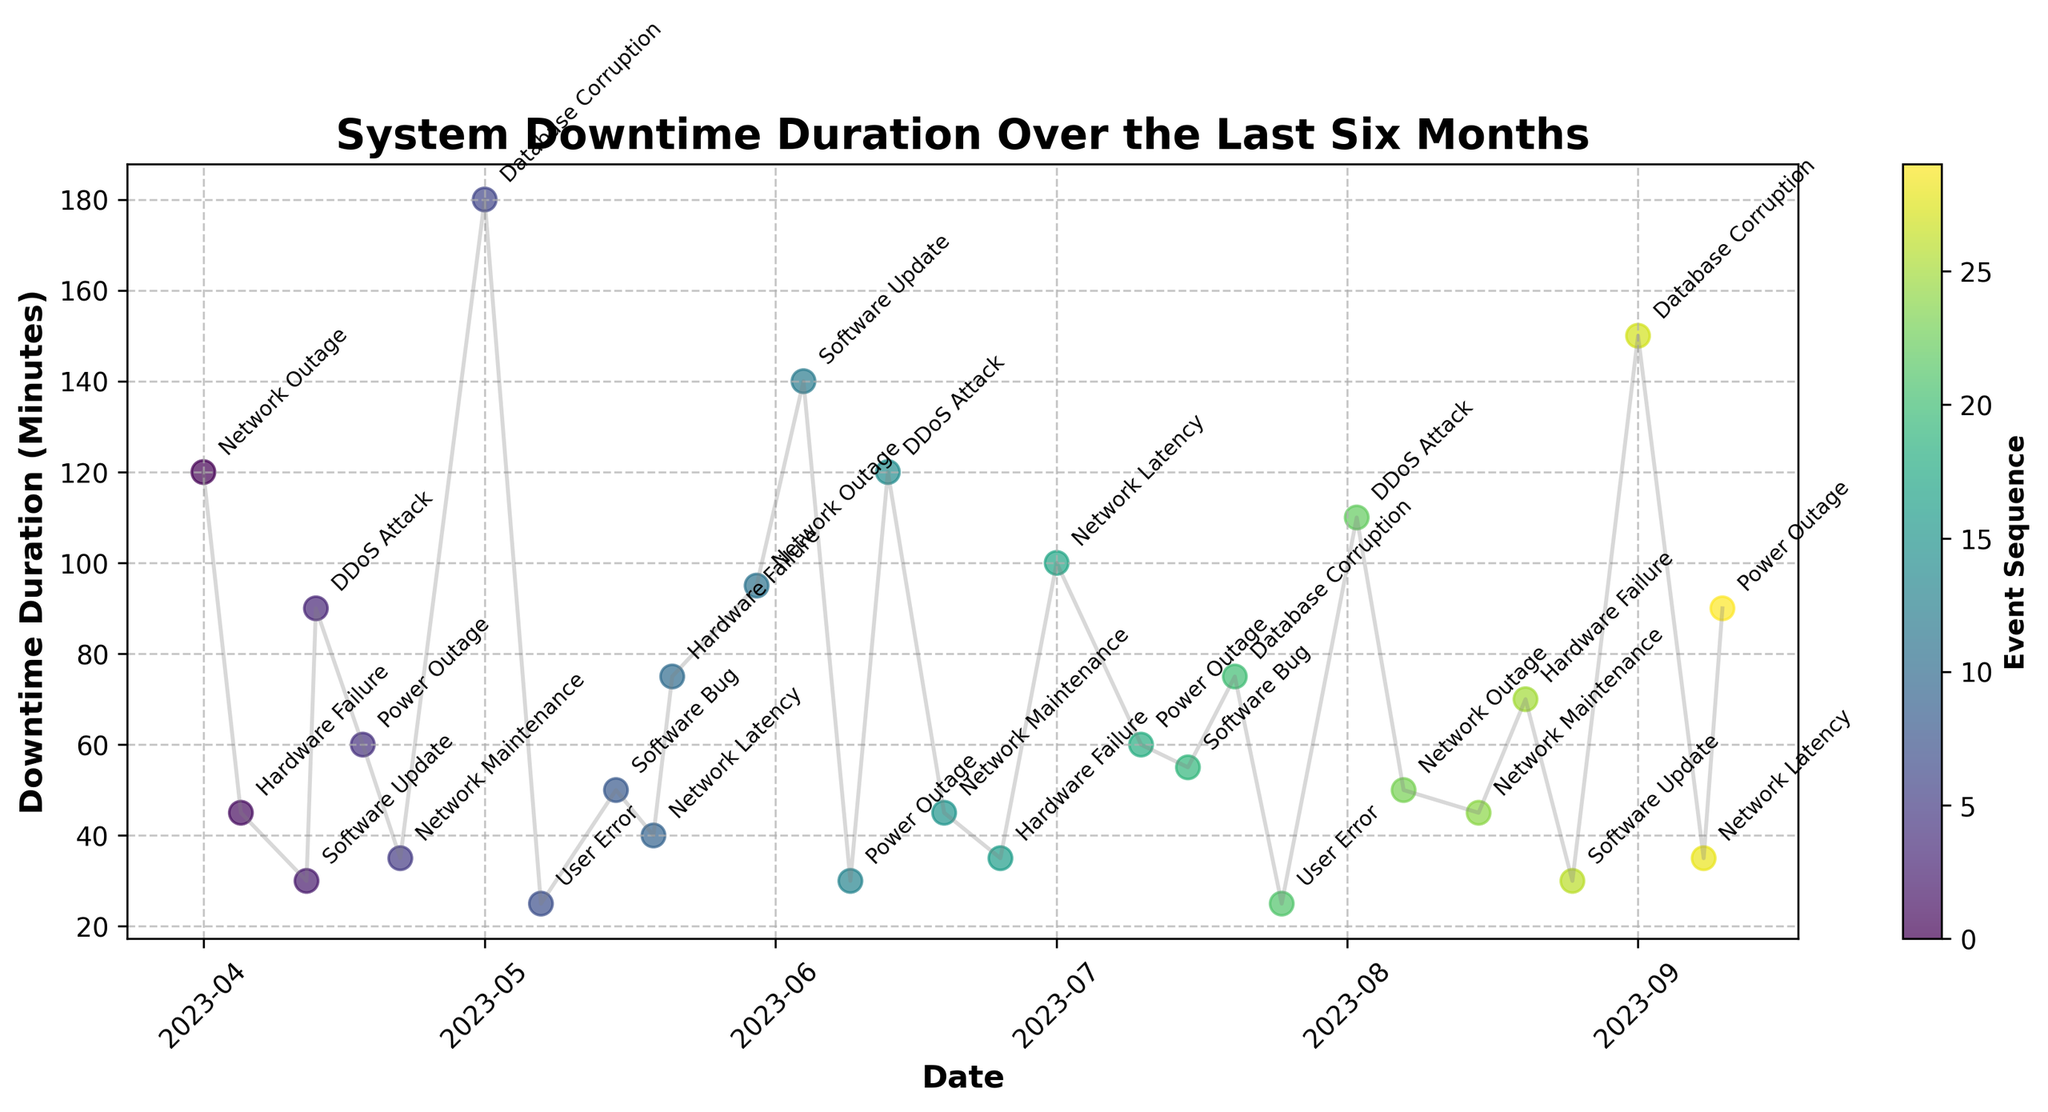what is the duration of the longest downtime event? By examining the plot, the longest downtime event appears to be on May 1st with a duration of 180 minutes.
Answer: 180 minutes what is the title of the plot? The title of the plot is located at the top center of the figure and reads 'System Downtime Duration Over the Last Six Months'.
Answer: 'System Downtime Duration Over the Last Six Months' How many downtime events are there in June? By looking at the dates and corresponding points in June (June 4, June 9, June 13, June 19, and June 25), we see there are five downtime events in June.
Answer: 5 which type of cause resulted in the maximum downtime duration? The maximum downtime duration is 180 minutes on May 1st, and the cause for this event is 'Database Corruption', as annotated on the plot.
Answer: 'Database Corruption' How does the duration of the DDoS attack on June 13 compare with the one on April 13? The plot shows that the downtime durations for DDoS attacks on April 13 and June 13 are 90 and 120 minutes, respectively. The June 13 DDoS attack is 30 minutes longer.
Answer: 30 minutes longer Are there any months without downtime events? By reviewing the distribution of points across the months, we see that every month from April to September has at least one downtime event plotted.
Answer: No what is the average duration of downtime events caused by Network Outage? The plot shows Network Outages occurred on April 1 (120 minutes), May 30 (95 minutes), and August 7 (50 minutes). The average is calculated as (120 + 95 + 50) / 3, which equals 88.33 minutes.
Answer: 88.33 minutes what is the total downtime duration experienced in August? The August downtime durations on the plot are: August 2 (110 minutes), August 7 (50 minutes), August 15 (45 minutes), August 20 (70 minutes), and August 25 (30 minutes). Adding these gives 110 + 50 + 45 + 70 + 30 = 305 minutes.
Answer: 305 minutes Are there more downtime events caused by Hardware Failure or Power Outage? By counting the number of points annotated with 'Hardware Failure' (April 5, May 21, June 25, August 20) and 'Power Outage' (April 18, June 9, July 10, September 10), both causes have 4 events each.
Answer: Equal 